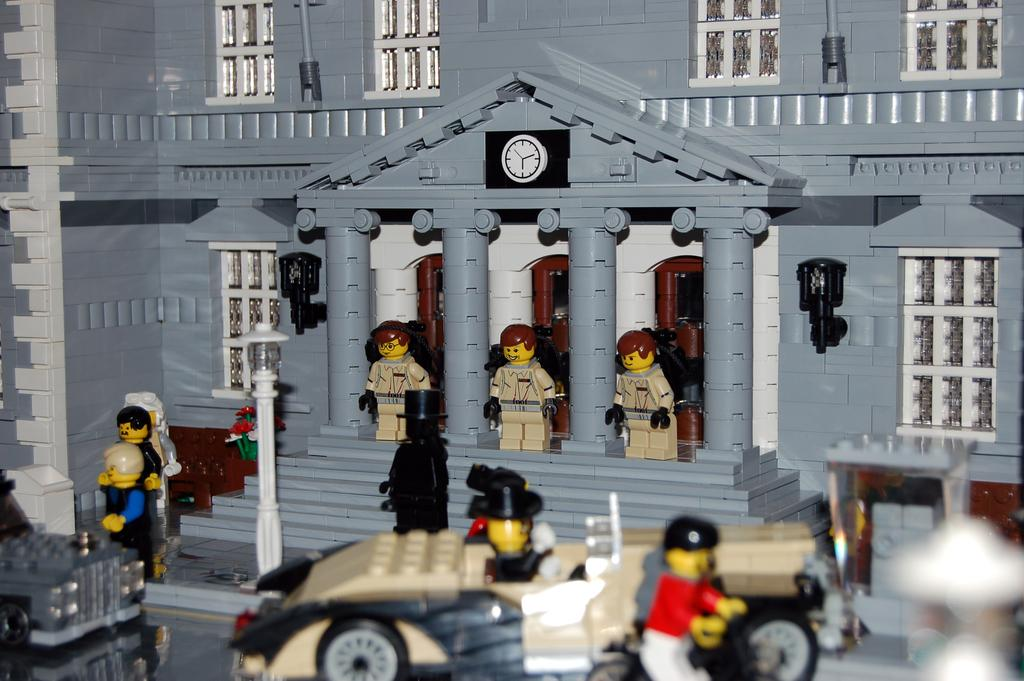What type of toy is depicted in the image? There is a toy house made with building blocks in the image. Are there any other types of toys visible in the image? Yes, there are two toy vehicles at the bottom of the image. Can you describe the overall theme of the toys in the image? The image contains many toys, primarily focused on a town or city setting. Where is the hen located in the image? There is no hen present in the image. What type of joke is being told by the mother in the image? There is no mother or joke present in the image. 